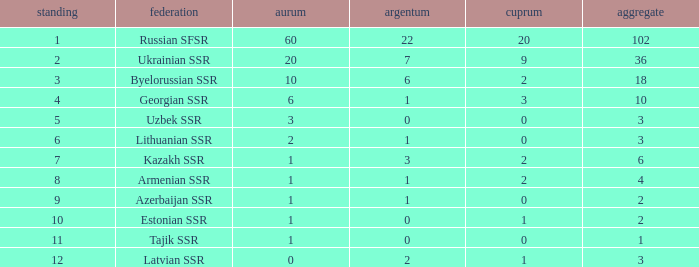What is the sum of silvers for teams with ranks over 3 and totals under 2? 0.0. 